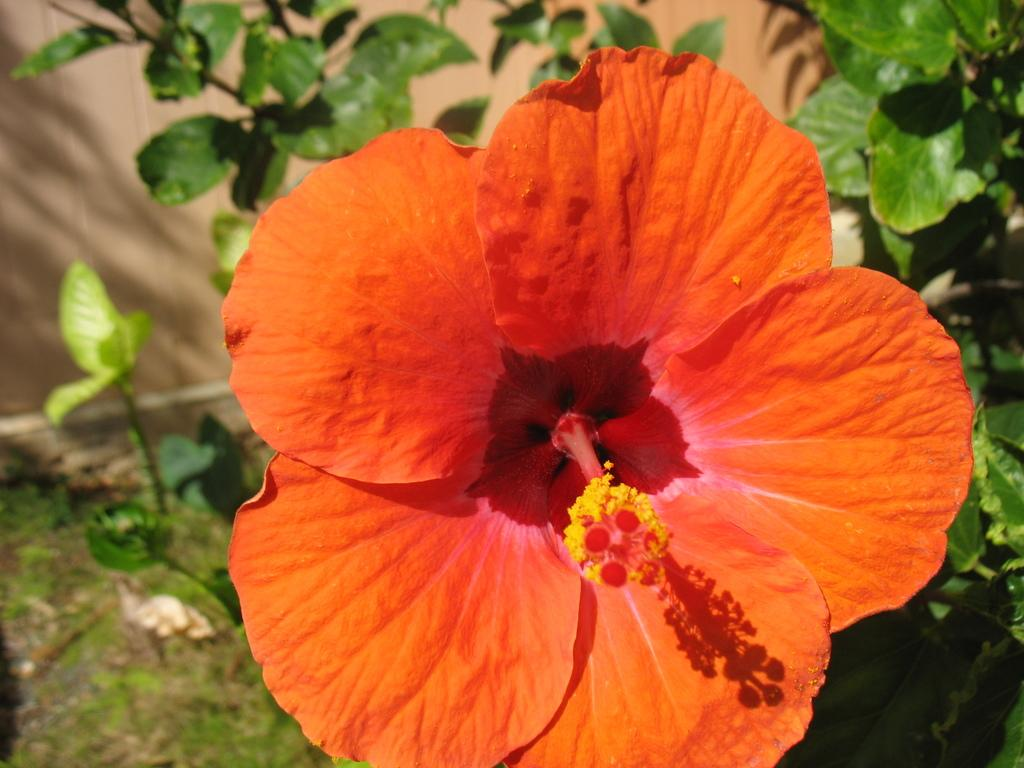What type of plant is in the image? There is a plant with a flower in the image. What can be seen at the bottom of the image? There is ground visible at the bottom of the image. What else is present on the plant besides the flower? There are leaves in the image. What is visible in the background of the image? There appears to be a building in the background of the image. What type of haircut does the beast have in the image? There is no beast present in the image, and therefore no haircut can be observed. 